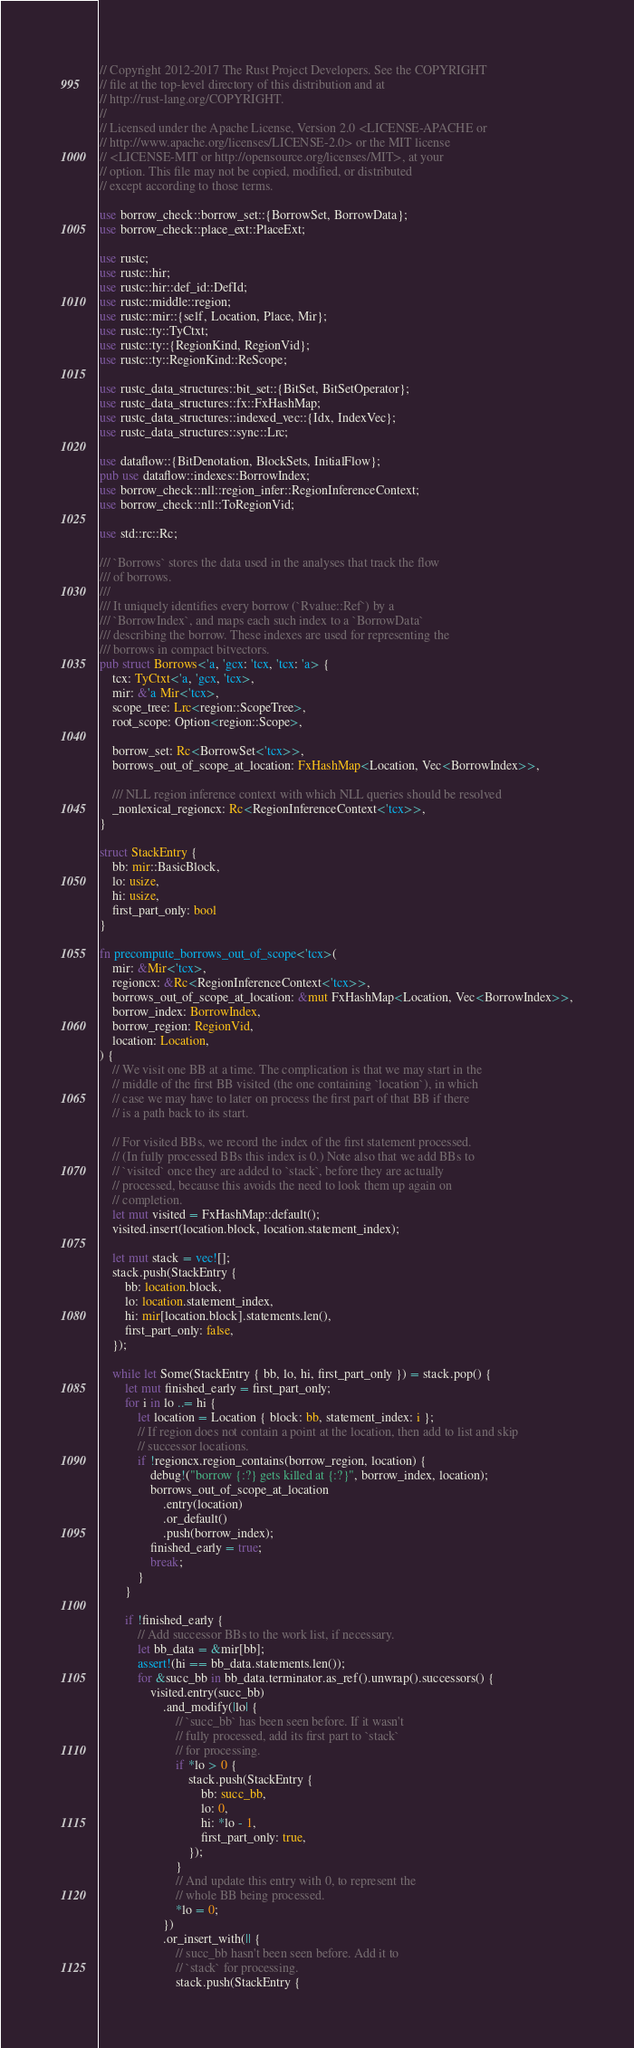<code> <loc_0><loc_0><loc_500><loc_500><_Rust_>// Copyright 2012-2017 The Rust Project Developers. See the COPYRIGHT
// file at the top-level directory of this distribution and at
// http://rust-lang.org/COPYRIGHT.
//
// Licensed under the Apache License, Version 2.0 <LICENSE-APACHE or
// http://www.apache.org/licenses/LICENSE-2.0> or the MIT license
// <LICENSE-MIT or http://opensource.org/licenses/MIT>, at your
// option. This file may not be copied, modified, or distributed
// except according to those terms.

use borrow_check::borrow_set::{BorrowSet, BorrowData};
use borrow_check::place_ext::PlaceExt;

use rustc;
use rustc::hir;
use rustc::hir::def_id::DefId;
use rustc::middle::region;
use rustc::mir::{self, Location, Place, Mir};
use rustc::ty::TyCtxt;
use rustc::ty::{RegionKind, RegionVid};
use rustc::ty::RegionKind::ReScope;

use rustc_data_structures::bit_set::{BitSet, BitSetOperator};
use rustc_data_structures::fx::FxHashMap;
use rustc_data_structures::indexed_vec::{Idx, IndexVec};
use rustc_data_structures::sync::Lrc;

use dataflow::{BitDenotation, BlockSets, InitialFlow};
pub use dataflow::indexes::BorrowIndex;
use borrow_check::nll::region_infer::RegionInferenceContext;
use borrow_check::nll::ToRegionVid;

use std::rc::Rc;

/// `Borrows` stores the data used in the analyses that track the flow
/// of borrows.
///
/// It uniquely identifies every borrow (`Rvalue::Ref`) by a
/// `BorrowIndex`, and maps each such index to a `BorrowData`
/// describing the borrow. These indexes are used for representing the
/// borrows in compact bitvectors.
pub struct Borrows<'a, 'gcx: 'tcx, 'tcx: 'a> {
    tcx: TyCtxt<'a, 'gcx, 'tcx>,
    mir: &'a Mir<'tcx>,
    scope_tree: Lrc<region::ScopeTree>,
    root_scope: Option<region::Scope>,

    borrow_set: Rc<BorrowSet<'tcx>>,
    borrows_out_of_scope_at_location: FxHashMap<Location, Vec<BorrowIndex>>,

    /// NLL region inference context with which NLL queries should be resolved
    _nonlexical_regioncx: Rc<RegionInferenceContext<'tcx>>,
}

struct StackEntry {
    bb: mir::BasicBlock,
    lo: usize,
    hi: usize,
    first_part_only: bool
}

fn precompute_borrows_out_of_scope<'tcx>(
    mir: &Mir<'tcx>,
    regioncx: &Rc<RegionInferenceContext<'tcx>>,
    borrows_out_of_scope_at_location: &mut FxHashMap<Location, Vec<BorrowIndex>>,
    borrow_index: BorrowIndex,
    borrow_region: RegionVid,
    location: Location,
) {
    // We visit one BB at a time. The complication is that we may start in the
    // middle of the first BB visited (the one containing `location`), in which
    // case we may have to later on process the first part of that BB if there
    // is a path back to its start.

    // For visited BBs, we record the index of the first statement processed.
    // (In fully processed BBs this index is 0.) Note also that we add BBs to
    // `visited` once they are added to `stack`, before they are actually
    // processed, because this avoids the need to look them up again on
    // completion.
    let mut visited = FxHashMap::default();
    visited.insert(location.block, location.statement_index);

    let mut stack = vec![];
    stack.push(StackEntry {
        bb: location.block,
        lo: location.statement_index,
        hi: mir[location.block].statements.len(),
        first_part_only: false,
    });

    while let Some(StackEntry { bb, lo, hi, first_part_only }) = stack.pop() {
        let mut finished_early = first_part_only;
        for i in lo ..= hi {
            let location = Location { block: bb, statement_index: i };
            // If region does not contain a point at the location, then add to list and skip
            // successor locations.
            if !regioncx.region_contains(borrow_region, location) {
                debug!("borrow {:?} gets killed at {:?}", borrow_index, location);
                borrows_out_of_scope_at_location
                    .entry(location)
                    .or_default()
                    .push(borrow_index);
                finished_early = true;
                break;
            }
        }

        if !finished_early {
            // Add successor BBs to the work list, if necessary.
            let bb_data = &mir[bb];
            assert!(hi == bb_data.statements.len());
            for &succ_bb in bb_data.terminator.as_ref().unwrap().successors() {
                visited.entry(succ_bb)
                    .and_modify(|lo| {
                        // `succ_bb` has been seen before. If it wasn't
                        // fully processed, add its first part to `stack`
                        // for processing.
                        if *lo > 0 {
                            stack.push(StackEntry {
                                bb: succ_bb,
                                lo: 0,
                                hi: *lo - 1,
                                first_part_only: true,
                            });
                        }
                        // And update this entry with 0, to represent the
                        // whole BB being processed.
                        *lo = 0;
                    })
                    .or_insert_with(|| {
                        // succ_bb hasn't been seen before. Add it to
                        // `stack` for processing.
                        stack.push(StackEntry {</code> 